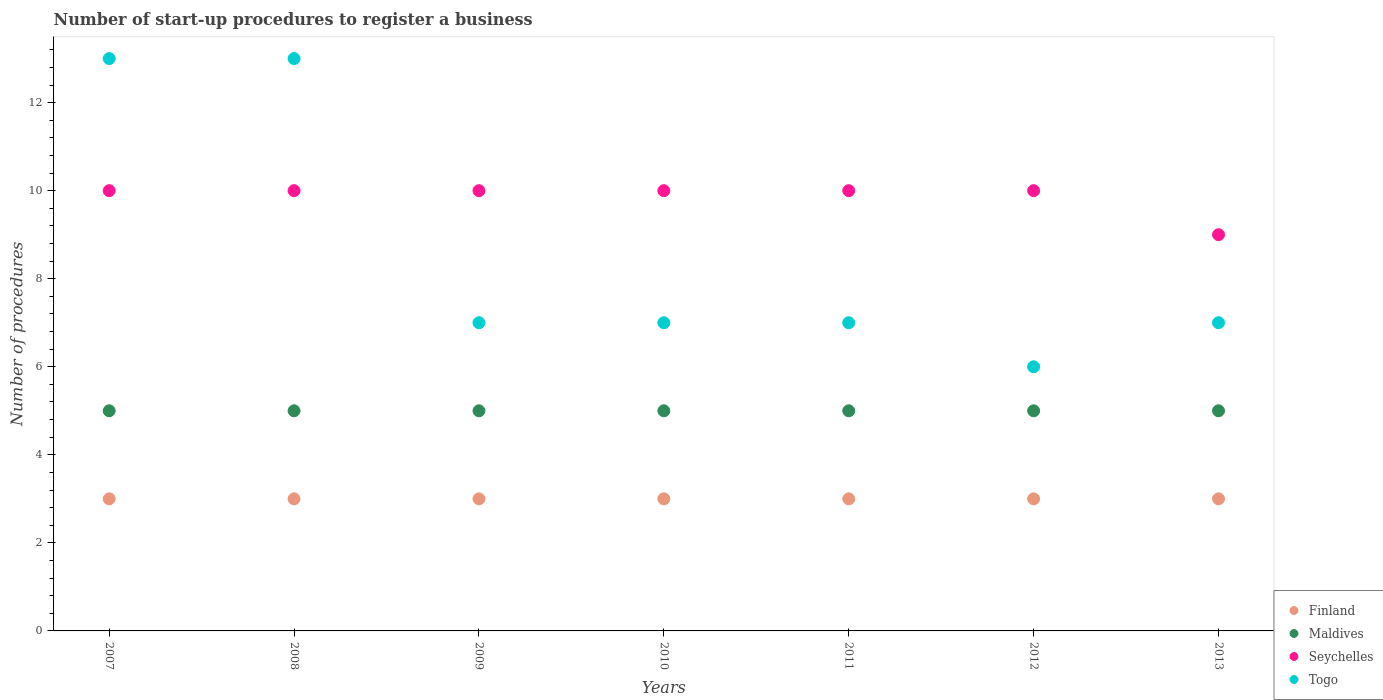Is the number of dotlines equal to the number of legend labels?
Offer a very short reply. Yes. What is the number of procedures required to register a business in Finland in 2013?
Offer a terse response. 3. Across all years, what is the maximum number of procedures required to register a business in Finland?
Offer a very short reply. 3. Across all years, what is the minimum number of procedures required to register a business in Seychelles?
Make the answer very short. 9. In which year was the number of procedures required to register a business in Maldives maximum?
Your response must be concise. 2007. In which year was the number of procedures required to register a business in Maldives minimum?
Your answer should be very brief. 2007. What is the total number of procedures required to register a business in Seychelles in the graph?
Offer a very short reply. 69. What is the difference between the number of procedures required to register a business in Seychelles in 2012 and that in 2013?
Make the answer very short. 1. What is the difference between the number of procedures required to register a business in Togo in 2007 and the number of procedures required to register a business in Seychelles in 2009?
Make the answer very short. 3. What is the average number of procedures required to register a business in Togo per year?
Your answer should be compact. 8.57. In the year 2010, what is the difference between the number of procedures required to register a business in Finland and number of procedures required to register a business in Maldives?
Offer a terse response. -2. In how many years, is the number of procedures required to register a business in Maldives greater than 12.4?
Provide a short and direct response. 0. Is the number of procedures required to register a business in Finland in 2007 less than that in 2013?
Your response must be concise. No. What is the difference between the highest and the lowest number of procedures required to register a business in Maldives?
Give a very brief answer. 0. Is the sum of the number of procedures required to register a business in Seychelles in 2007 and 2010 greater than the maximum number of procedures required to register a business in Togo across all years?
Offer a terse response. Yes. Does the number of procedures required to register a business in Maldives monotonically increase over the years?
Provide a succinct answer. No. Does the graph contain any zero values?
Your response must be concise. No. What is the title of the graph?
Your answer should be very brief. Number of start-up procedures to register a business. What is the label or title of the X-axis?
Offer a very short reply. Years. What is the label or title of the Y-axis?
Offer a terse response. Number of procedures. What is the Number of procedures in Finland in 2008?
Make the answer very short. 3. What is the Number of procedures of Seychelles in 2008?
Keep it short and to the point. 10. What is the Number of procedures in Togo in 2009?
Provide a short and direct response. 7. What is the Number of procedures of Finland in 2010?
Your answer should be compact. 3. What is the Number of procedures of Maldives in 2010?
Offer a very short reply. 5. What is the Number of procedures of Seychelles in 2010?
Keep it short and to the point. 10. What is the Number of procedures of Maldives in 2012?
Give a very brief answer. 5. What is the Number of procedures in Seychelles in 2012?
Ensure brevity in your answer.  10. What is the Number of procedures in Togo in 2012?
Provide a succinct answer. 6. What is the Number of procedures of Finland in 2013?
Your response must be concise. 3. What is the Number of procedures in Seychelles in 2013?
Ensure brevity in your answer.  9. Across all years, what is the maximum Number of procedures in Finland?
Offer a very short reply. 3. Across all years, what is the maximum Number of procedures in Seychelles?
Offer a terse response. 10. Across all years, what is the maximum Number of procedures in Togo?
Your response must be concise. 13. Across all years, what is the minimum Number of procedures in Seychelles?
Your answer should be compact. 9. Across all years, what is the minimum Number of procedures in Togo?
Your answer should be very brief. 6. What is the total Number of procedures in Seychelles in the graph?
Your answer should be very brief. 69. What is the difference between the Number of procedures of Finland in 2007 and that in 2008?
Your answer should be very brief. 0. What is the difference between the Number of procedures in Maldives in 2007 and that in 2008?
Make the answer very short. 0. What is the difference between the Number of procedures of Seychelles in 2007 and that in 2008?
Offer a terse response. 0. What is the difference between the Number of procedures of Togo in 2007 and that in 2008?
Offer a very short reply. 0. What is the difference between the Number of procedures in Maldives in 2007 and that in 2009?
Give a very brief answer. 0. What is the difference between the Number of procedures of Seychelles in 2007 and that in 2009?
Provide a short and direct response. 0. What is the difference between the Number of procedures in Togo in 2007 and that in 2009?
Offer a very short reply. 6. What is the difference between the Number of procedures of Finland in 2007 and that in 2010?
Provide a short and direct response. 0. What is the difference between the Number of procedures in Seychelles in 2007 and that in 2010?
Offer a very short reply. 0. What is the difference between the Number of procedures of Maldives in 2007 and that in 2011?
Offer a terse response. 0. What is the difference between the Number of procedures in Seychelles in 2007 and that in 2011?
Your answer should be very brief. 0. What is the difference between the Number of procedures in Finland in 2007 and that in 2012?
Your response must be concise. 0. What is the difference between the Number of procedures of Togo in 2007 and that in 2012?
Provide a short and direct response. 7. What is the difference between the Number of procedures in Maldives in 2008 and that in 2009?
Provide a succinct answer. 0. What is the difference between the Number of procedures of Finland in 2008 and that in 2010?
Offer a very short reply. 0. What is the difference between the Number of procedures in Maldives in 2008 and that in 2010?
Your answer should be very brief. 0. What is the difference between the Number of procedures of Togo in 2008 and that in 2010?
Ensure brevity in your answer.  6. What is the difference between the Number of procedures of Seychelles in 2008 and that in 2011?
Your answer should be compact. 0. What is the difference between the Number of procedures of Seychelles in 2008 and that in 2012?
Ensure brevity in your answer.  0. What is the difference between the Number of procedures of Togo in 2008 and that in 2012?
Offer a terse response. 7. What is the difference between the Number of procedures of Finland in 2008 and that in 2013?
Your answer should be very brief. 0. What is the difference between the Number of procedures in Togo in 2008 and that in 2013?
Ensure brevity in your answer.  6. What is the difference between the Number of procedures in Finland in 2009 and that in 2010?
Give a very brief answer. 0. What is the difference between the Number of procedures of Maldives in 2009 and that in 2010?
Offer a very short reply. 0. What is the difference between the Number of procedures of Togo in 2009 and that in 2010?
Offer a terse response. 0. What is the difference between the Number of procedures of Finland in 2009 and that in 2011?
Your answer should be compact. 0. What is the difference between the Number of procedures of Maldives in 2009 and that in 2011?
Provide a succinct answer. 0. What is the difference between the Number of procedures of Seychelles in 2009 and that in 2011?
Keep it short and to the point. 0. What is the difference between the Number of procedures of Maldives in 2009 and that in 2012?
Give a very brief answer. 0. What is the difference between the Number of procedures of Togo in 2009 and that in 2012?
Offer a terse response. 1. What is the difference between the Number of procedures in Finland in 2009 and that in 2013?
Your response must be concise. 0. What is the difference between the Number of procedures of Maldives in 2009 and that in 2013?
Your answer should be compact. 0. What is the difference between the Number of procedures of Seychelles in 2010 and that in 2011?
Ensure brevity in your answer.  0. What is the difference between the Number of procedures in Finland in 2010 and that in 2012?
Your response must be concise. 0. What is the difference between the Number of procedures in Seychelles in 2010 and that in 2012?
Your answer should be very brief. 0. What is the difference between the Number of procedures of Togo in 2010 and that in 2012?
Provide a succinct answer. 1. What is the difference between the Number of procedures of Finland in 2010 and that in 2013?
Make the answer very short. 0. What is the difference between the Number of procedures in Finland in 2011 and that in 2012?
Offer a terse response. 0. What is the difference between the Number of procedures in Maldives in 2011 and that in 2012?
Your answer should be very brief. 0. What is the difference between the Number of procedures of Togo in 2011 and that in 2012?
Give a very brief answer. 1. What is the difference between the Number of procedures in Maldives in 2011 and that in 2013?
Provide a succinct answer. 0. What is the difference between the Number of procedures in Maldives in 2012 and that in 2013?
Keep it short and to the point. 0. What is the difference between the Number of procedures in Seychelles in 2012 and that in 2013?
Ensure brevity in your answer.  1. What is the difference between the Number of procedures in Finland in 2007 and the Number of procedures in Maldives in 2008?
Provide a succinct answer. -2. What is the difference between the Number of procedures in Finland in 2007 and the Number of procedures in Seychelles in 2008?
Your answer should be very brief. -7. What is the difference between the Number of procedures of Seychelles in 2007 and the Number of procedures of Togo in 2008?
Make the answer very short. -3. What is the difference between the Number of procedures in Finland in 2007 and the Number of procedures in Maldives in 2009?
Your answer should be very brief. -2. What is the difference between the Number of procedures of Finland in 2007 and the Number of procedures of Seychelles in 2009?
Provide a succinct answer. -7. What is the difference between the Number of procedures in Maldives in 2007 and the Number of procedures in Seychelles in 2009?
Provide a succinct answer. -5. What is the difference between the Number of procedures of Seychelles in 2007 and the Number of procedures of Togo in 2010?
Ensure brevity in your answer.  3. What is the difference between the Number of procedures of Finland in 2007 and the Number of procedures of Seychelles in 2011?
Offer a very short reply. -7. What is the difference between the Number of procedures in Maldives in 2007 and the Number of procedures in Togo in 2011?
Offer a terse response. -2. What is the difference between the Number of procedures in Seychelles in 2007 and the Number of procedures in Togo in 2011?
Keep it short and to the point. 3. What is the difference between the Number of procedures of Finland in 2007 and the Number of procedures of Maldives in 2012?
Provide a succinct answer. -2. What is the difference between the Number of procedures of Finland in 2007 and the Number of procedures of Seychelles in 2012?
Provide a short and direct response. -7. What is the difference between the Number of procedures of Finland in 2007 and the Number of procedures of Togo in 2012?
Provide a short and direct response. -3. What is the difference between the Number of procedures of Maldives in 2007 and the Number of procedures of Seychelles in 2012?
Give a very brief answer. -5. What is the difference between the Number of procedures of Maldives in 2007 and the Number of procedures of Togo in 2012?
Make the answer very short. -1. What is the difference between the Number of procedures of Seychelles in 2007 and the Number of procedures of Togo in 2012?
Provide a short and direct response. 4. What is the difference between the Number of procedures in Finland in 2007 and the Number of procedures in Maldives in 2013?
Your answer should be compact. -2. What is the difference between the Number of procedures of Finland in 2008 and the Number of procedures of Maldives in 2009?
Your answer should be compact. -2. What is the difference between the Number of procedures of Maldives in 2008 and the Number of procedures of Seychelles in 2010?
Make the answer very short. -5. What is the difference between the Number of procedures of Finland in 2008 and the Number of procedures of Seychelles in 2011?
Keep it short and to the point. -7. What is the difference between the Number of procedures of Maldives in 2008 and the Number of procedures of Togo in 2011?
Provide a short and direct response. -2. What is the difference between the Number of procedures in Finland in 2008 and the Number of procedures in Maldives in 2012?
Provide a short and direct response. -2. What is the difference between the Number of procedures of Seychelles in 2008 and the Number of procedures of Togo in 2012?
Give a very brief answer. 4. What is the difference between the Number of procedures of Finland in 2008 and the Number of procedures of Maldives in 2013?
Keep it short and to the point. -2. What is the difference between the Number of procedures in Finland in 2008 and the Number of procedures in Seychelles in 2013?
Offer a very short reply. -6. What is the difference between the Number of procedures of Seychelles in 2008 and the Number of procedures of Togo in 2013?
Keep it short and to the point. 3. What is the difference between the Number of procedures in Finland in 2009 and the Number of procedures in Seychelles in 2010?
Give a very brief answer. -7. What is the difference between the Number of procedures of Finland in 2009 and the Number of procedures of Togo in 2010?
Provide a succinct answer. -4. What is the difference between the Number of procedures in Maldives in 2009 and the Number of procedures in Togo in 2010?
Your answer should be compact. -2. What is the difference between the Number of procedures in Finland in 2009 and the Number of procedures in Togo in 2011?
Your answer should be very brief. -4. What is the difference between the Number of procedures in Seychelles in 2009 and the Number of procedures in Togo in 2011?
Provide a short and direct response. 3. What is the difference between the Number of procedures of Finland in 2009 and the Number of procedures of Maldives in 2012?
Offer a terse response. -2. What is the difference between the Number of procedures in Maldives in 2009 and the Number of procedures in Seychelles in 2012?
Make the answer very short. -5. What is the difference between the Number of procedures in Maldives in 2009 and the Number of procedures in Togo in 2012?
Keep it short and to the point. -1. What is the difference between the Number of procedures in Seychelles in 2009 and the Number of procedures in Togo in 2012?
Provide a succinct answer. 4. What is the difference between the Number of procedures of Finland in 2009 and the Number of procedures of Maldives in 2013?
Your answer should be very brief. -2. What is the difference between the Number of procedures in Finland in 2009 and the Number of procedures in Togo in 2013?
Your response must be concise. -4. What is the difference between the Number of procedures in Maldives in 2009 and the Number of procedures in Seychelles in 2013?
Provide a succinct answer. -4. What is the difference between the Number of procedures in Finland in 2010 and the Number of procedures in Maldives in 2011?
Offer a very short reply. -2. What is the difference between the Number of procedures in Finland in 2010 and the Number of procedures in Togo in 2011?
Ensure brevity in your answer.  -4. What is the difference between the Number of procedures of Maldives in 2010 and the Number of procedures of Togo in 2011?
Give a very brief answer. -2. What is the difference between the Number of procedures in Seychelles in 2010 and the Number of procedures in Togo in 2011?
Your answer should be very brief. 3. What is the difference between the Number of procedures in Finland in 2010 and the Number of procedures in Maldives in 2012?
Ensure brevity in your answer.  -2. What is the difference between the Number of procedures of Maldives in 2010 and the Number of procedures of Togo in 2012?
Keep it short and to the point. -1. What is the difference between the Number of procedures of Seychelles in 2010 and the Number of procedures of Togo in 2012?
Offer a terse response. 4. What is the difference between the Number of procedures of Finland in 2010 and the Number of procedures of Togo in 2013?
Your response must be concise. -4. What is the difference between the Number of procedures of Maldives in 2010 and the Number of procedures of Seychelles in 2013?
Provide a succinct answer. -4. What is the difference between the Number of procedures of Seychelles in 2010 and the Number of procedures of Togo in 2013?
Give a very brief answer. 3. What is the difference between the Number of procedures of Finland in 2011 and the Number of procedures of Seychelles in 2012?
Provide a short and direct response. -7. What is the difference between the Number of procedures in Seychelles in 2011 and the Number of procedures in Togo in 2012?
Your answer should be compact. 4. What is the difference between the Number of procedures of Finland in 2011 and the Number of procedures of Maldives in 2013?
Offer a terse response. -2. What is the difference between the Number of procedures of Finland in 2011 and the Number of procedures of Seychelles in 2013?
Make the answer very short. -6. What is the difference between the Number of procedures of Finland in 2011 and the Number of procedures of Togo in 2013?
Your answer should be compact. -4. What is the difference between the Number of procedures of Seychelles in 2011 and the Number of procedures of Togo in 2013?
Offer a very short reply. 3. What is the difference between the Number of procedures of Maldives in 2012 and the Number of procedures of Seychelles in 2013?
Your response must be concise. -4. What is the average Number of procedures of Finland per year?
Your answer should be very brief. 3. What is the average Number of procedures of Maldives per year?
Make the answer very short. 5. What is the average Number of procedures in Seychelles per year?
Your answer should be very brief. 9.86. What is the average Number of procedures in Togo per year?
Make the answer very short. 8.57. In the year 2007, what is the difference between the Number of procedures of Finland and Number of procedures of Togo?
Offer a terse response. -10. In the year 2007, what is the difference between the Number of procedures in Maldives and Number of procedures in Togo?
Make the answer very short. -8. In the year 2007, what is the difference between the Number of procedures in Seychelles and Number of procedures in Togo?
Offer a very short reply. -3. In the year 2008, what is the difference between the Number of procedures of Finland and Number of procedures of Maldives?
Ensure brevity in your answer.  -2. In the year 2008, what is the difference between the Number of procedures in Finland and Number of procedures in Seychelles?
Provide a succinct answer. -7. In the year 2008, what is the difference between the Number of procedures of Seychelles and Number of procedures of Togo?
Ensure brevity in your answer.  -3. In the year 2009, what is the difference between the Number of procedures of Finland and Number of procedures of Maldives?
Your answer should be very brief. -2. In the year 2009, what is the difference between the Number of procedures in Finland and Number of procedures in Seychelles?
Your answer should be compact. -7. In the year 2009, what is the difference between the Number of procedures in Finland and Number of procedures in Togo?
Offer a terse response. -4. In the year 2009, what is the difference between the Number of procedures of Maldives and Number of procedures of Seychelles?
Offer a terse response. -5. In the year 2009, what is the difference between the Number of procedures in Maldives and Number of procedures in Togo?
Your answer should be compact. -2. In the year 2010, what is the difference between the Number of procedures of Finland and Number of procedures of Togo?
Offer a very short reply. -4. In the year 2010, what is the difference between the Number of procedures of Maldives and Number of procedures of Togo?
Ensure brevity in your answer.  -2. In the year 2011, what is the difference between the Number of procedures in Finland and Number of procedures in Maldives?
Provide a succinct answer. -2. In the year 2011, what is the difference between the Number of procedures in Maldives and Number of procedures in Togo?
Your answer should be very brief. -2. In the year 2011, what is the difference between the Number of procedures of Seychelles and Number of procedures of Togo?
Ensure brevity in your answer.  3. In the year 2012, what is the difference between the Number of procedures of Finland and Number of procedures of Maldives?
Keep it short and to the point. -2. In the year 2012, what is the difference between the Number of procedures in Finland and Number of procedures in Seychelles?
Ensure brevity in your answer.  -7. In the year 2012, what is the difference between the Number of procedures in Finland and Number of procedures in Togo?
Your answer should be very brief. -3. In the year 2012, what is the difference between the Number of procedures in Seychelles and Number of procedures in Togo?
Your answer should be very brief. 4. In the year 2013, what is the difference between the Number of procedures in Finland and Number of procedures in Maldives?
Give a very brief answer. -2. In the year 2013, what is the difference between the Number of procedures of Finland and Number of procedures of Togo?
Provide a short and direct response. -4. In the year 2013, what is the difference between the Number of procedures of Maldives and Number of procedures of Seychelles?
Ensure brevity in your answer.  -4. What is the ratio of the Number of procedures in Finland in 2007 to that in 2008?
Your answer should be compact. 1. What is the ratio of the Number of procedures of Maldives in 2007 to that in 2008?
Provide a succinct answer. 1. What is the ratio of the Number of procedures of Seychelles in 2007 to that in 2009?
Offer a very short reply. 1. What is the ratio of the Number of procedures of Togo in 2007 to that in 2009?
Your response must be concise. 1.86. What is the ratio of the Number of procedures of Maldives in 2007 to that in 2010?
Your response must be concise. 1. What is the ratio of the Number of procedures of Seychelles in 2007 to that in 2010?
Keep it short and to the point. 1. What is the ratio of the Number of procedures in Togo in 2007 to that in 2010?
Provide a succinct answer. 1.86. What is the ratio of the Number of procedures in Finland in 2007 to that in 2011?
Your response must be concise. 1. What is the ratio of the Number of procedures in Maldives in 2007 to that in 2011?
Offer a terse response. 1. What is the ratio of the Number of procedures of Togo in 2007 to that in 2011?
Give a very brief answer. 1.86. What is the ratio of the Number of procedures in Finland in 2007 to that in 2012?
Your response must be concise. 1. What is the ratio of the Number of procedures of Maldives in 2007 to that in 2012?
Provide a succinct answer. 1. What is the ratio of the Number of procedures of Togo in 2007 to that in 2012?
Give a very brief answer. 2.17. What is the ratio of the Number of procedures in Finland in 2007 to that in 2013?
Give a very brief answer. 1. What is the ratio of the Number of procedures in Seychelles in 2007 to that in 2013?
Make the answer very short. 1.11. What is the ratio of the Number of procedures of Togo in 2007 to that in 2013?
Offer a terse response. 1.86. What is the ratio of the Number of procedures in Maldives in 2008 to that in 2009?
Offer a very short reply. 1. What is the ratio of the Number of procedures of Seychelles in 2008 to that in 2009?
Make the answer very short. 1. What is the ratio of the Number of procedures in Togo in 2008 to that in 2009?
Ensure brevity in your answer.  1.86. What is the ratio of the Number of procedures of Seychelles in 2008 to that in 2010?
Make the answer very short. 1. What is the ratio of the Number of procedures of Togo in 2008 to that in 2010?
Ensure brevity in your answer.  1.86. What is the ratio of the Number of procedures of Maldives in 2008 to that in 2011?
Your answer should be compact. 1. What is the ratio of the Number of procedures of Togo in 2008 to that in 2011?
Provide a short and direct response. 1.86. What is the ratio of the Number of procedures of Togo in 2008 to that in 2012?
Give a very brief answer. 2.17. What is the ratio of the Number of procedures of Maldives in 2008 to that in 2013?
Offer a terse response. 1. What is the ratio of the Number of procedures in Togo in 2008 to that in 2013?
Offer a terse response. 1.86. What is the ratio of the Number of procedures of Togo in 2009 to that in 2010?
Keep it short and to the point. 1. What is the ratio of the Number of procedures in Finland in 2009 to that in 2011?
Your answer should be compact. 1. What is the ratio of the Number of procedures of Seychelles in 2009 to that in 2011?
Make the answer very short. 1. What is the ratio of the Number of procedures in Togo in 2009 to that in 2011?
Your answer should be compact. 1. What is the ratio of the Number of procedures in Seychelles in 2009 to that in 2012?
Provide a succinct answer. 1. What is the ratio of the Number of procedures in Togo in 2009 to that in 2012?
Provide a succinct answer. 1.17. What is the ratio of the Number of procedures of Finland in 2009 to that in 2013?
Your answer should be compact. 1. What is the ratio of the Number of procedures in Maldives in 2009 to that in 2013?
Offer a terse response. 1. What is the ratio of the Number of procedures of Seychelles in 2009 to that in 2013?
Ensure brevity in your answer.  1.11. What is the ratio of the Number of procedures in Togo in 2009 to that in 2013?
Your response must be concise. 1. What is the ratio of the Number of procedures of Finland in 2010 to that in 2011?
Offer a terse response. 1. What is the ratio of the Number of procedures of Seychelles in 2010 to that in 2011?
Provide a short and direct response. 1. What is the ratio of the Number of procedures in Togo in 2010 to that in 2011?
Your answer should be compact. 1. What is the ratio of the Number of procedures in Maldives in 2010 to that in 2012?
Your response must be concise. 1. What is the ratio of the Number of procedures of Togo in 2010 to that in 2012?
Offer a very short reply. 1.17. What is the ratio of the Number of procedures in Togo in 2010 to that in 2013?
Keep it short and to the point. 1. What is the ratio of the Number of procedures in Finland in 2011 to that in 2012?
Ensure brevity in your answer.  1. What is the ratio of the Number of procedures in Maldives in 2011 to that in 2013?
Give a very brief answer. 1. What is the ratio of the Number of procedures of Seychelles in 2011 to that in 2013?
Give a very brief answer. 1.11. What is the ratio of the Number of procedures of Finland in 2012 to that in 2013?
Give a very brief answer. 1. What is the ratio of the Number of procedures of Maldives in 2012 to that in 2013?
Your response must be concise. 1. What is the difference between the highest and the second highest Number of procedures of Finland?
Ensure brevity in your answer.  0. What is the difference between the highest and the lowest Number of procedures of Maldives?
Make the answer very short. 0. What is the difference between the highest and the lowest Number of procedures in Seychelles?
Your response must be concise. 1. 